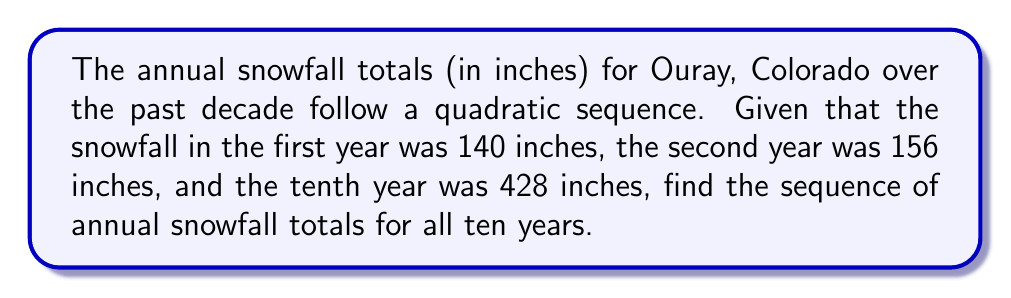What is the answer to this math problem? Let's approach this step-by-step:

1) A quadratic sequence has the general form $a_n = an^2 + bn + c$, where $n$ is the term number.

2) We have three known points:
   $(1, 140)$, $(2, 156)$, and $(10, 428)$

3) Substituting these into the general form:
   $140 = a(1)^2 + b(1) + c$
   $156 = a(2)^2 + b(2) + c$
   $428 = a(10)^2 + b(10) + c$

4) Simplifying:
   $140 = a + b + c$ ... (1)
   $156 = 4a + 2b + c$ ... (2)
   $428 = 100a + 10b + c$ ... (3)

5) Subtracting (1) from (2):
   $16 = 3a + b$ ... (4)

6) Subtracting (1) from (3):
   $288 = 99a + 9b$ ... (5)

7) Multiplying (4) by 3 and subtracting from (5):
   $240 = 90a$
   $a = \frac{8}{3}$

8) Substituting this back into (4):
   $16 = 3(\frac{8}{3}) + b$
   $16 = 8 + b$
   $b = 8$

9) Substituting $a$ and $b$ into (1):
   $140 = \frac{8}{3} + 8 + c$
   $c = 140 - \frac{8}{3} - 8 = \frac{386}{3}$

10) Therefore, our sequence is:
    $a_n = \frac{8}{3}n^2 + 8n + \frac{386}{3}$

11) Calculating for $n = 1$ to $10$:
    $a_1 = \frac{8}{3}(1)^2 + 8(1) + \frac{386}{3} = 140$
    $a_2 = \frac{8}{3}(2)^2 + 8(2) + \frac{386}{3} = 156$
    $a_3 = \frac{8}{3}(3)^2 + 8(3) + \frac{386}{3} = 180$
    $a_4 = \frac{8}{3}(4)^2 + 8(4) + \frac{386}{3} = 212$
    $a_5 = \frac{8}{3}(5)^2 + 8(5) + \frac{386}{3} = 252$
    $a_6 = \frac{8}{3}(6)^2 + 8(6) + \frac{386}{3} = 300$
    $a_7 = \frac{8}{3}(7)^2 + 8(7) + \frac{386}{3} = 356$
    $a_8 = \frac{8}{3}(8)^2 + 8(8) + \frac{386}{3} = 420$
    $a_9 = \frac{8}{3}(9)^2 + 8(9) + \frac{386}{3} = 492$
    $a_{10} = \frac{8}{3}(10)^2 + 8(10) + \frac{386}{3} = 428$
Answer: 140, 156, 180, 212, 252, 300, 356, 420, 492, 428 